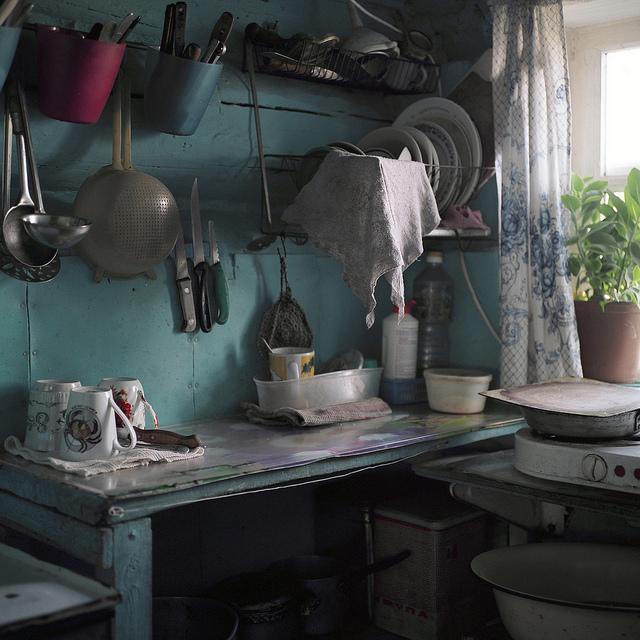How many mugs are there?
Give a very brief answer. 3. How many species are on the rack?
Give a very brief answer. 0. How many bottles can be seen?
Give a very brief answer. 2. How many spoons can you see?
Give a very brief answer. 2. How many cups are visible?
Give a very brief answer. 2. How many bowls are in the photo?
Give a very brief answer. 3. 